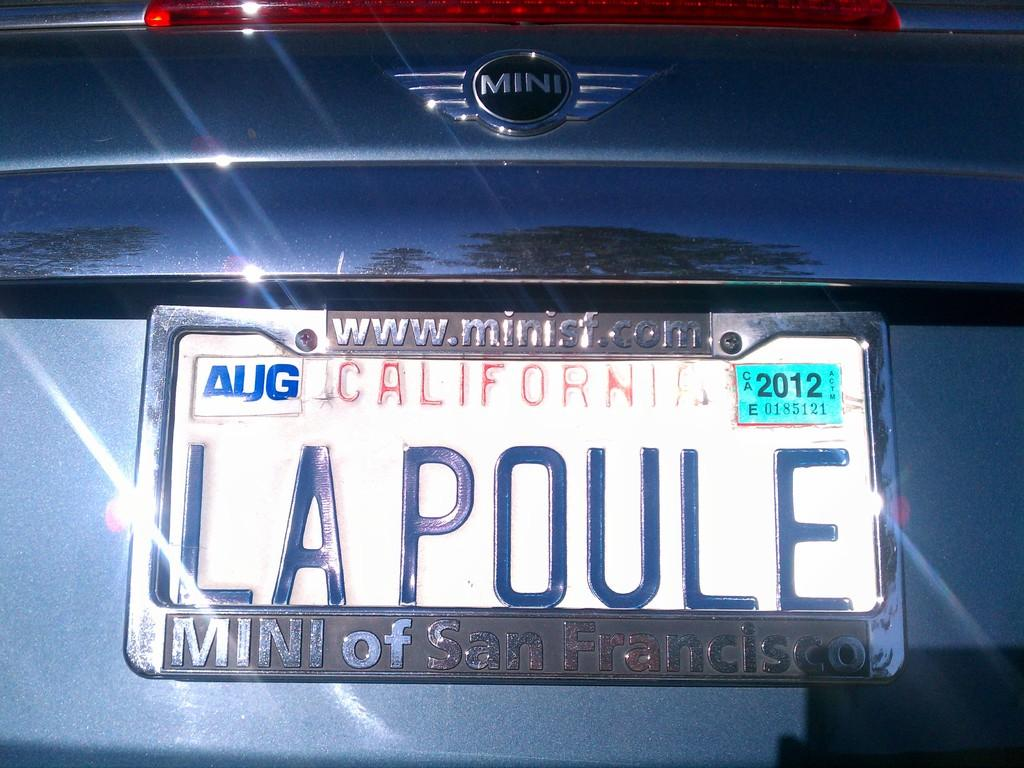Provide a one-sentence caption for the provided image. The back of a car that was purchased in San Francisco. 